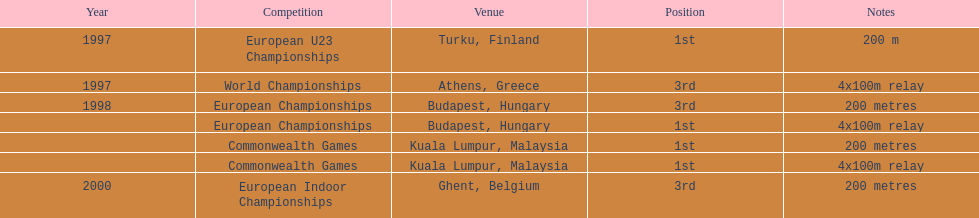Catalog the tournaments that include the equivalent relay as world championships held in athens, greece. European Championships, Commonwealth Games. 